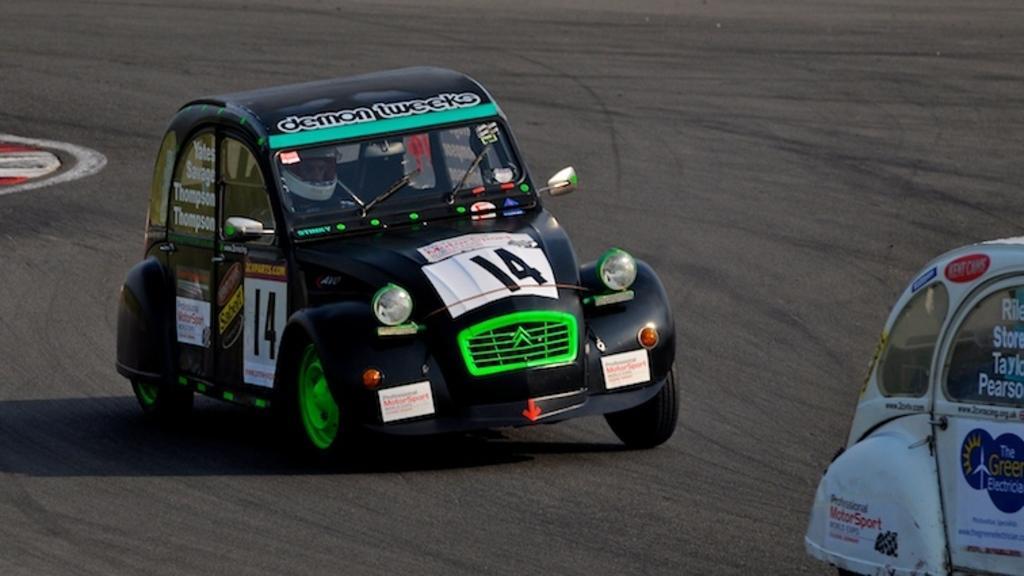Please provide a concise description of this image. In this image I can see the cars with some text written on it. I can also see the road. 